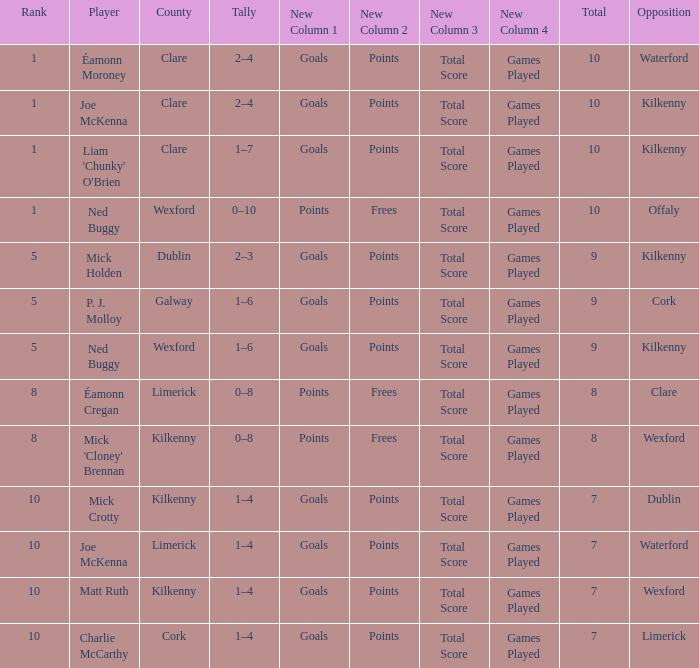Which County has a Rank larger than 8, and a Player of joe mckenna? Limerick. 